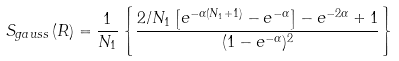<formula> <loc_0><loc_0><loc_500><loc_500>S _ { g a u s s } \left ( R \right ) = \frac { 1 } { N _ { 1 } } \left \{ \frac { 2 / N _ { 1 } \left [ e ^ { - \alpha ( N _ { 1 } + 1 ) } - e ^ { - \alpha } \right ] - e ^ { - 2 \alpha } + 1 } { ( 1 - e ^ { - \alpha } ) ^ { 2 } } \right \}</formula> 